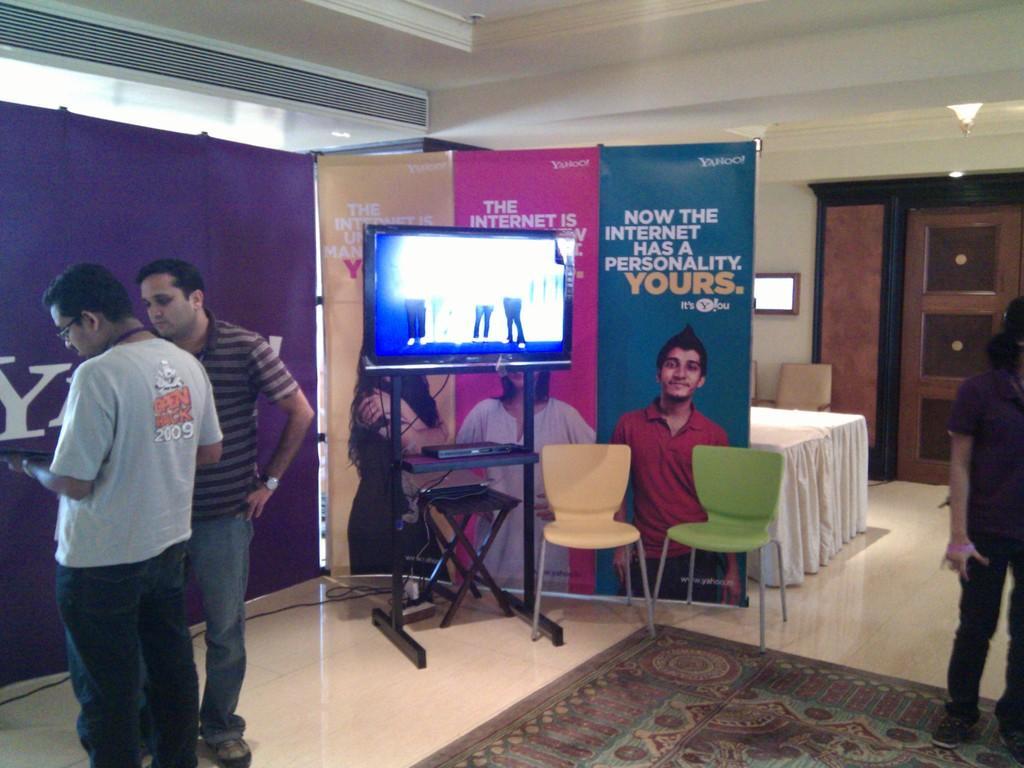Please provide a concise description of this image. A picture inside of a room. We can able to see number of banners. In-front of this banner there is a monitor. This persons are standing. We can able to see chairs and tables. Floor with carpet. On this poster there are persons. 